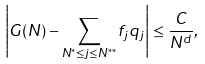Convert formula to latex. <formula><loc_0><loc_0><loc_500><loc_500>\left | G ( N ) - \sum _ { N ^ { * } \leq j \leq N ^ { * * } } f _ { j } q _ { j } \right | \leq \frac { C } { N ^ { d } } ,</formula> 